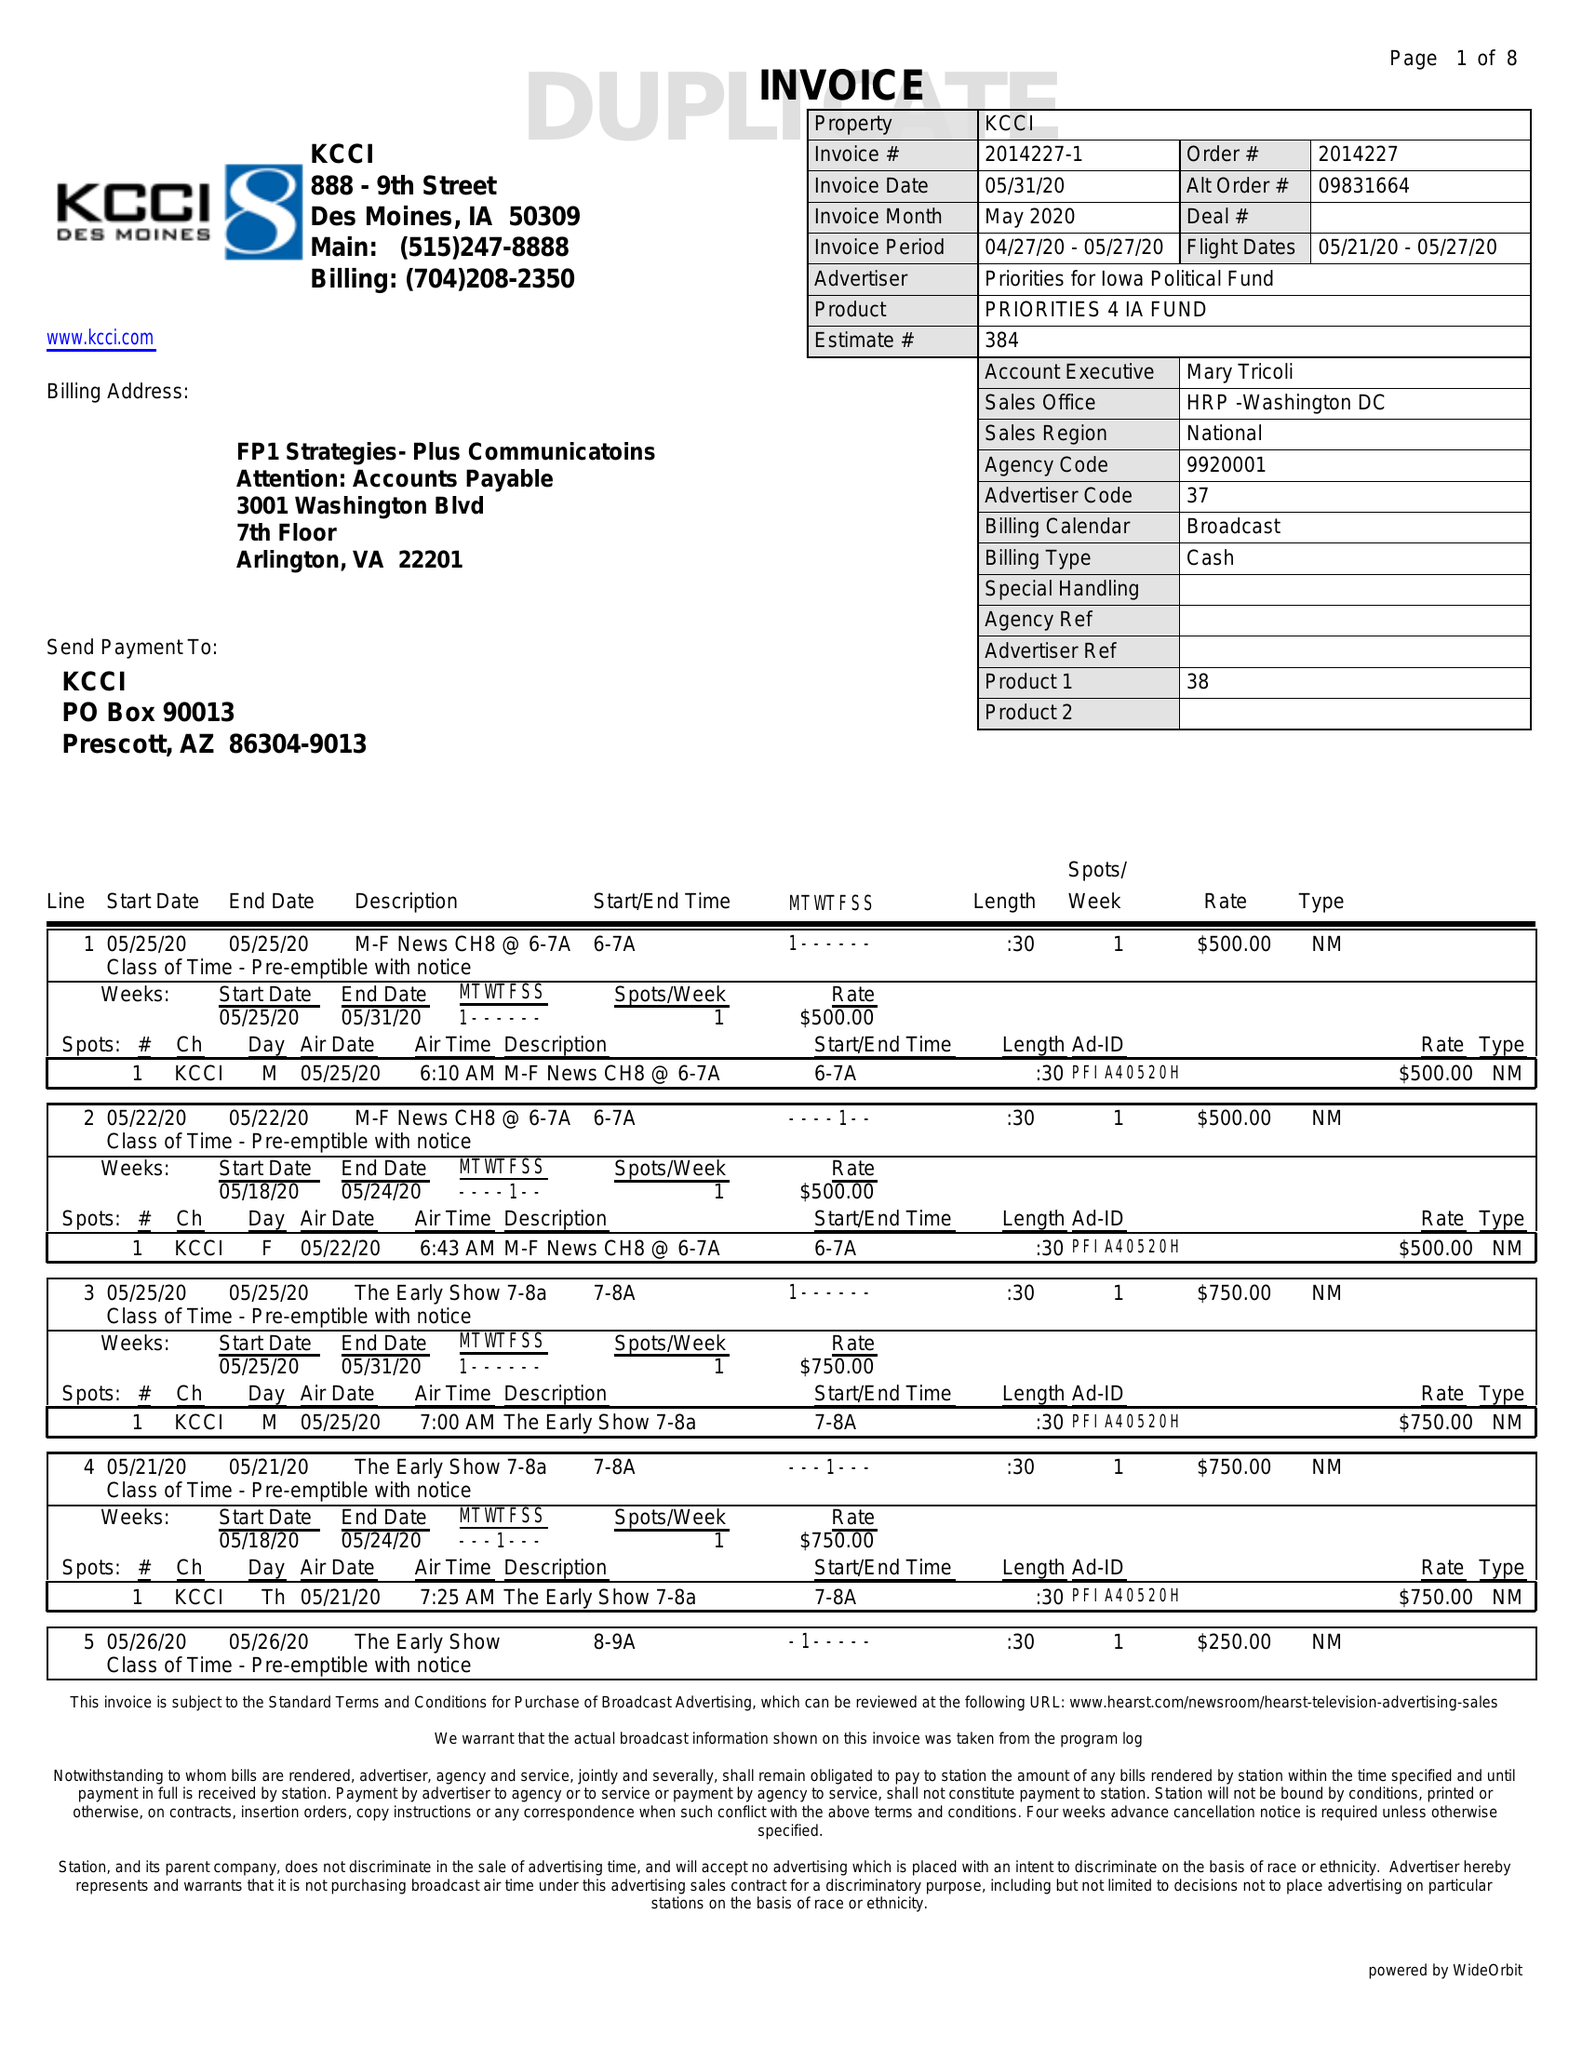What is the value for the flight_from?
Answer the question using a single word or phrase. 05/21/20 